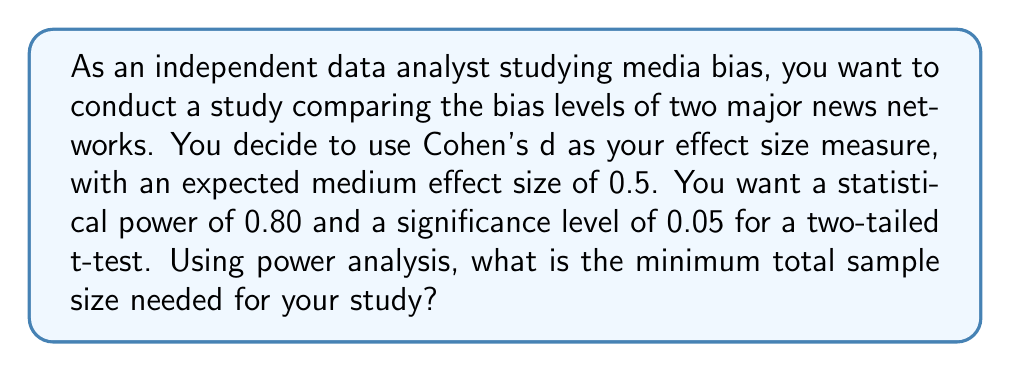Could you help me with this problem? To determine the optimal sample size for this media bias study, we'll use power analysis. We'll follow these steps:

1. Identify the parameters:
   - Effect size (Cohen's d) = 0.5 (medium effect)
   - Desired power = 0.80
   - Significance level (α) = 0.05
   - Test type: Two-tailed t-test

2. Use the power analysis formula for a two-sample t-test:

   $$n = \frac{2(z_{1-\alpha/2} + z_{1-\beta})^2}{\delta^2}$$

   Where:
   - $n$ is the sample size per group
   - $z_{1-\alpha/2}$ is the critical value for the significance level
   - $z_{1-\beta}$ is the critical value for the desired power
   - $\delta$ is the standardized effect size (Cohen's d)

3. Find the critical values:
   - For α = 0.05 (two-tailed), $z_{1-\alpha/2} = 1.96$
   - For power = 0.80, $z_{1-\beta} = 0.84$

4. Plug the values into the formula:

   $$n = \frac{2(1.96 + 0.84)^2}{0.5^2} = \frac{2(2.8)^2}{0.25} = \frac{15.68}{0.25} = 62.72$$

5. Round up to the nearest whole number:
   $n ≈ 63$ per group

6. Calculate the total sample size:
   Total sample size = $2n = 2 * 63 = 126$

Therefore, the minimum total sample size needed for the study is 126 participants.
Answer: 126 